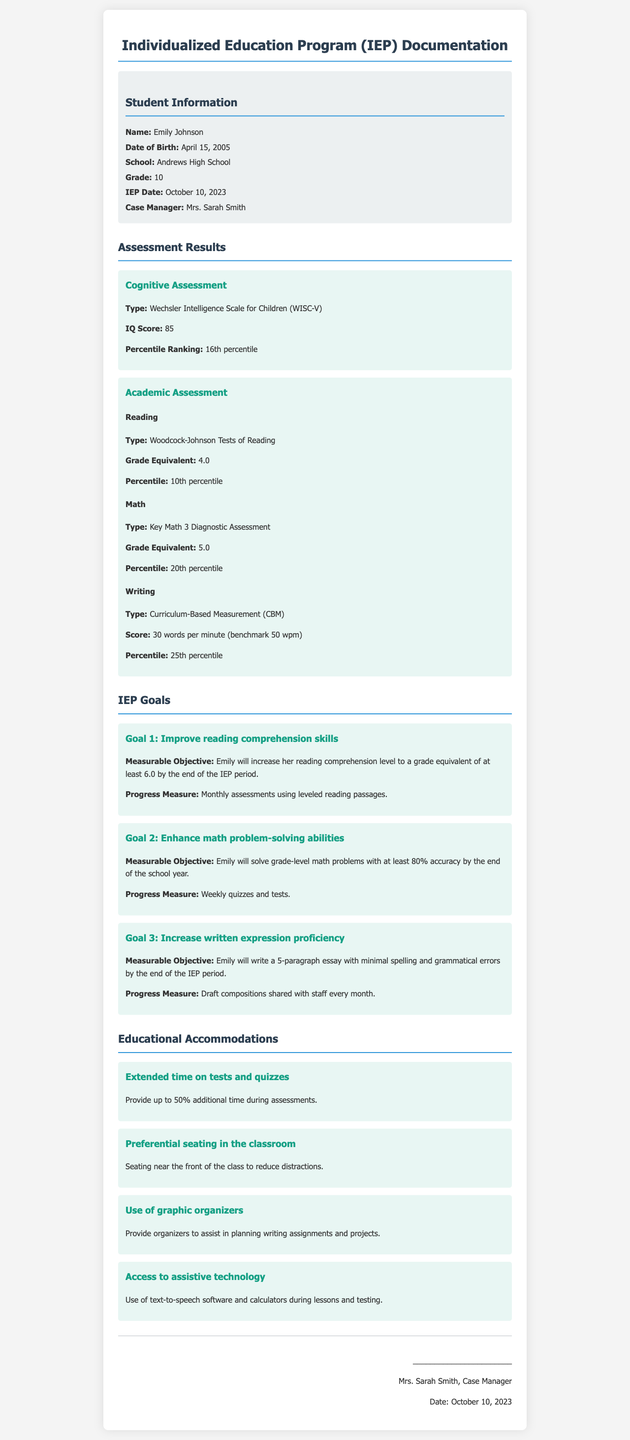What is the name of the student? The student's name is listed in the document under Student Information.
Answer: Emily Johnson What is the IQ score from the cognitive assessment? The IQ score is provided in the Cognitive Assessment section of the document.
Answer: 85 What is the grade equivalent for Emily's Reading skills? The grade equivalent for Reading is mentioned in the Academic Assessment section.
Answer: 4.0 What is the measurable objective for Goal 2? The measurable objective for Goal 2 can be found under the IEP Goals section.
Answer: Emily will solve grade-level math problems with at least 80% accuracy by the end of the school year How much additional time is provided during assessments? The specific time accommodation is stated in the Educational Accommodations section.
Answer: 50% additional time What is the percentile ranking for Emily's Math skills? The percentile ranking for Math is stated in the Academic Assessment section of the document.
Answer: 20th percentile What type of assessment was used for reading? The document specifies the type of assessment for reading in the Academic Assessment section.
Answer: Woodcock-Johnson Tests of Reading What is the date of the IEP meeting? The date of the IEP meeting is provided under Student Information.
Answer: October 10, 2023 What is the name of the case manager? The case manager's name is found in the Student Information section of the document.
Answer: Mrs. Sarah Smith 